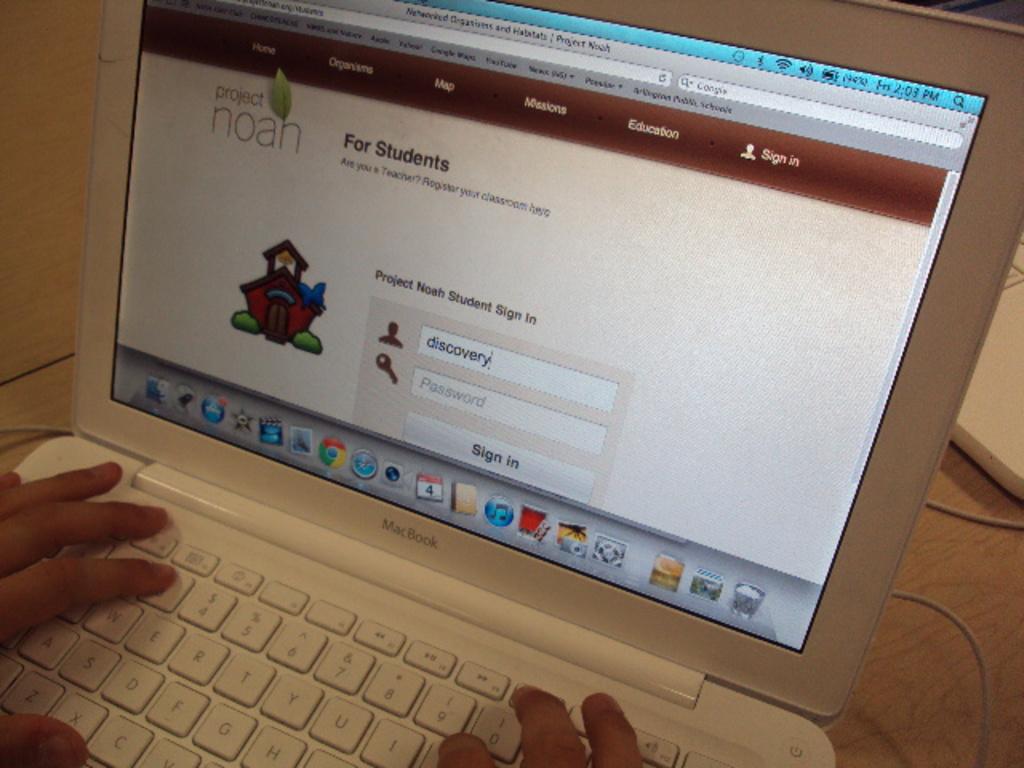What page is this for? students or teachers?
Give a very brief answer. Students. What project is this site?
Give a very brief answer. Noah. 